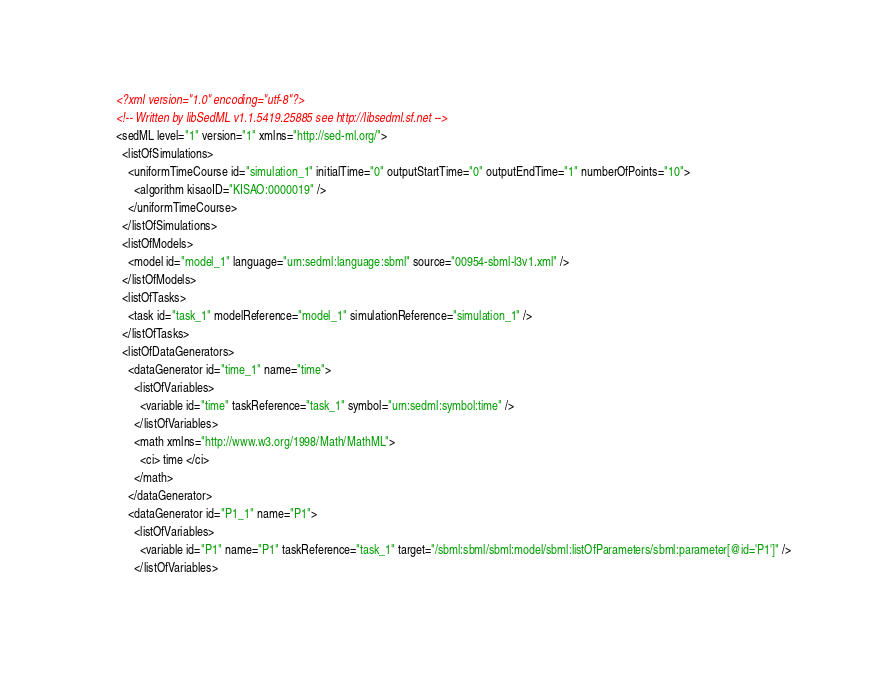Convert code to text. <code><loc_0><loc_0><loc_500><loc_500><_XML_><?xml version="1.0" encoding="utf-8"?>
<!-- Written by libSedML v1.1.5419.25885 see http://libsedml.sf.net -->
<sedML level="1" version="1" xmlns="http://sed-ml.org/">
  <listOfSimulations>
    <uniformTimeCourse id="simulation_1" initialTime="0" outputStartTime="0" outputEndTime="1" numberOfPoints="10">
      <algorithm kisaoID="KISAO:0000019" />
    </uniformTimeCourse>
  </listOfSimulations>
  <listOfModels>
    <model id="model_1" language="urn:sedml:language:sbml" source="00954-sbml-l3v1.xml" />
  </listOfModels>
  <listOfTasks>
    <task id="task_1" modelReference="model_1" simulationReference="simulation_1" />
  </listOfTasks>
  <listOfDataGenerators>
    <dataGenerator id="time_1" name="time">
      <listOfVariables>
        <variable id="time" taskReference="task_1" symbol="urn:sedml:symbol:time" />
      </listOfVariables>
      <math xmlns="http://www.w3.org/1998/Math/MathML">
        <ci> time </ci>
      </math>
    </dataGenerator>
    <dataGenerator id="P1_1" name="P1">
      <listOfVariables>
        <variable id="P1" name="P1" taskReference="task_1" target="/sbml:sbml/sbml:model/sbml:listOfParameters/sbml:parameter[@id='P1']" />
      </listOfVariables></code> 